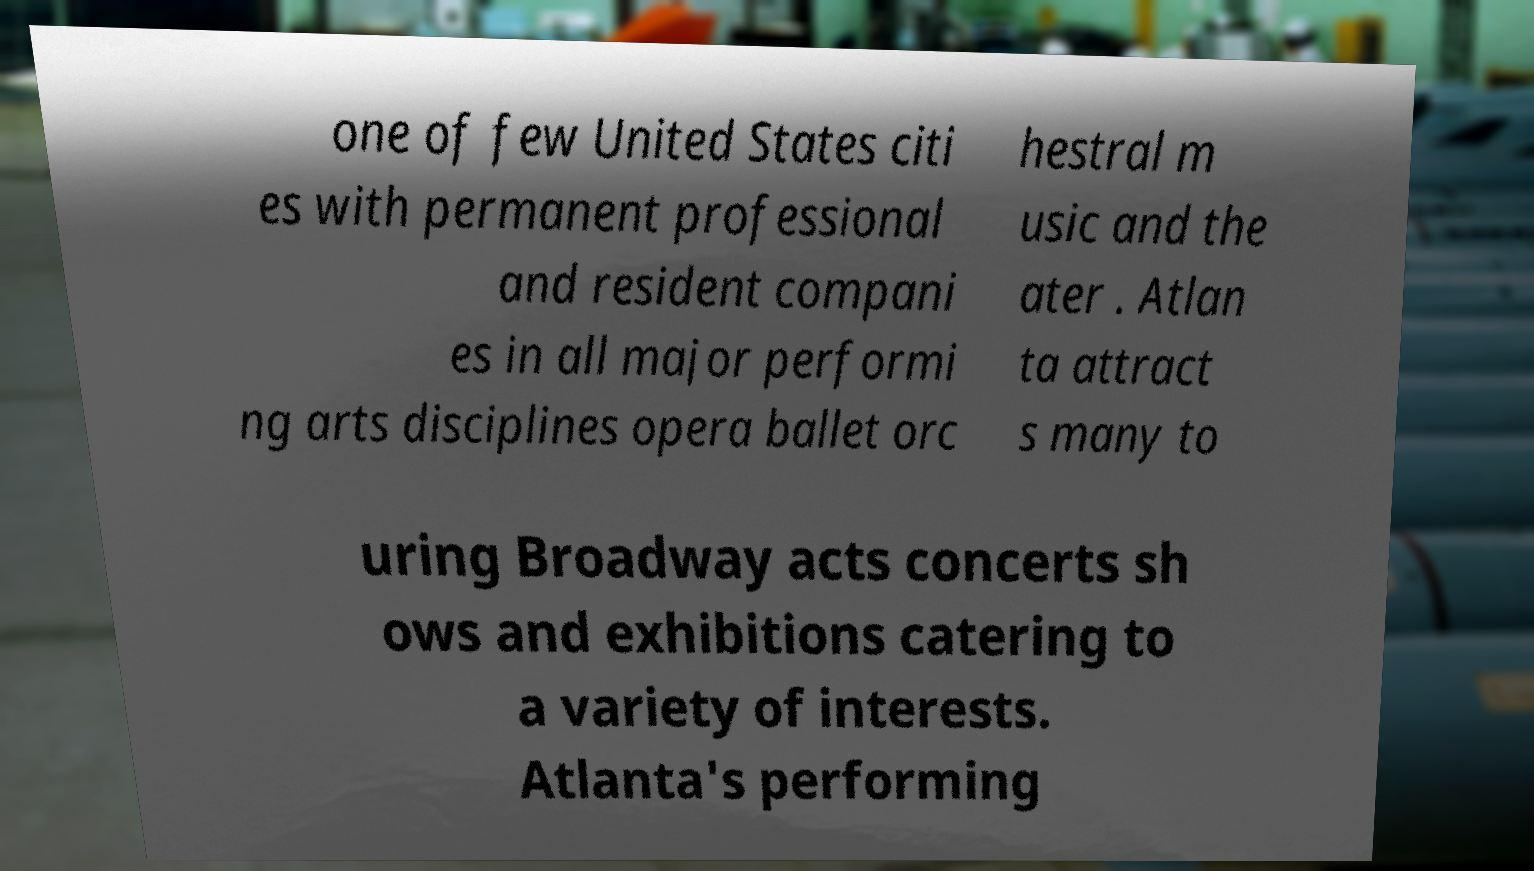There's text embedded in this image that I need extracted. Can you transcribe it verbatim? one of few United States citi es with permanent professional and resident compani es in all major performi ng arts disciplines opera ballet orc hestral m usic and the ater . Atlan ta attract s many to uring Broadway acts concerts sh ows and exhibitions catering to a variety of interests. Atlanta's performing 